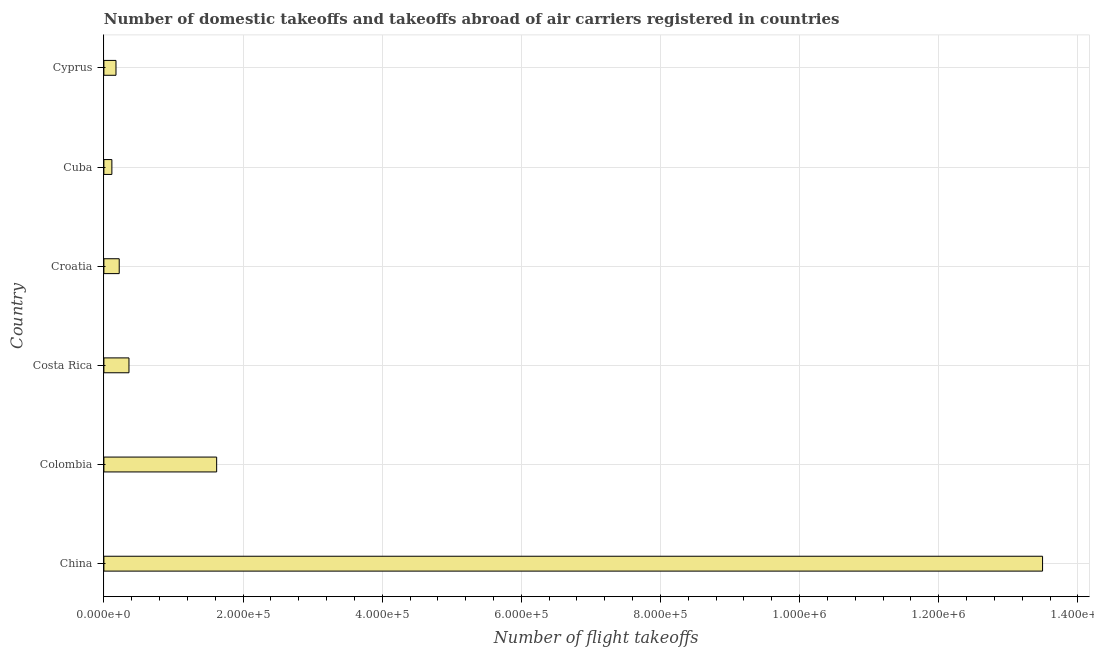Does the graph contain grids?
Offer a terse response. Yes. What is the title of the graph?
Offer a very short reply. Number of domestic takeoffs and takeoffs abroad of air carriers registered in countries. What is the label or title of the X-axis?
Give a very brief answer. Number of flight takeoffs. What is the number of flight takeoffs in China?
Give a very brief answer. 1.35e+06. Across all countries, what is the maximum number of flight takeoffs?
Give a very brief answer. 1.35e+06. Across all countries, what is the minimum number of flight takeoffs?
Make the answer very short. 1.15e+04. In which country was the number of flight takeoffs minimum?
Provide a succinct answer. Cuba. What is the sum of the number of flight takeoffs?
Offer a terse response. 1.60e+06. What is the difference between the number of flight takeoffs in Colombia and Croatia?
Offer a very short reply. 1.40e+05. What is the average number of flight takeoffs per country?
Offer a very short reply. 2.66e+05. What is the median number of flight takeoffs?
Keep it short and to the point. 2.90e+04. What is the ratio of the number of flight takeoffs in Colombia to that in Costa Rica?
Your answer should be compact. 4.5. Is the number of flight takeoffs in Costa Rica less than that in Croatia?
Provide a short and direct response. No. What is the difference between the highest and the second highest number of flight takeoffs?
Provide a short and direct response. 1.19e+06. Is the sum of the number of flight takeoffs in Cuba and Cyprus greater than the maximum number of flight takeoffs across all countries?
Provide a short and direct response. No. What is the difference between the highest and the lowest number of flight takeoffs?
Keep it short and to the point. 1.34e+06. How many countries are there in the graph?
Your response must be concise. 6. What is the difference between two consecutive major ticks on the X-axis?
Your answer should be very brief. 2.00e+05. What is the Number of flight takeoffs in China?
Your response must be concise. 1.35e+06. What is the Number of flight takeoffs of Colombia?
Give a very brief answer. 1.62e+05. What is the Number of flight takeoffs of Costa Rica?
Give a very brief answer. 3.60e+04. What is the Number of flight takeoffs in Croatia?
Offer a very short reply. 2.20e+04. What is the Number of flight takeoffs in Cuba?
Make the answer very short. 1.15e+04. What is the Number of flight takeoffs of Cyprus?
Offer a very short reply. 1.74e+04. What is the difference between the Number of flight takeoffs in China and Colombia?
Ensure brevity in your answer.  1.19e+06. What is the difference between the Number of flight takeoffs in China and Costa Rica?
Give a very brief answer. 1.31e+06. What is the difference between the Number of flight takeoffs in China and Croatia?
Your response must be concise. 1.33e+06. What is the difference between the Number of flight takeoffs in China and Cuba?
Your answer should be very brief. 1.34e+06. What is the difference between the Number of flight takeoffs in China and Cyprus?
Provide a short and direct response. 1.33e+06. What is the difference between the Number of flight takeoffs in Colombia and Costa Rica?
Your response must be concise. 1.26e+05. What is the difference between the Number of flight takeoffs in Colombia and Croatia?
Provide a succinct answer. 1.40e+05. What is the difference between the Number of flight takeoffs in Colombia and Cuba?
Your answer should be compact. 1.51e+05. What is the difference between the Number of flight takeoffs in Colombia and Cyprus?
Make the answer very short. 1.45e+05. What is the difference between the Number of flight takeoffs in Costa Rica and Croatia?
Your answer should be compact. 1.40e+04. What is the difference between the Number of flight takeoffs in Costa Rica and Cuba?
Keep it short and to the point. 2.46e+04. What is the difference between the Number of flight takeoffs in Costa Rica and Cyprus?
Your answer should be compact. 1.87e+04. What is the difference between the Number of flight takeoffs in Croatia and Cuba?
Your answer should be compact. 1.05e+04. What is the difference between the Number of flight takeoffs in Croatia and Cyprus?
Give a very brief answer. 4639. What is the difference between the Number of flight takeoffs in Cuba and Cyprus?
Make the answer very short. -5908. What is the ratio of the Number of flight takeoffs in China to that in Colombia?
Provide a succinct answer. 8.32. What is the ratio of the Number of flight takeoffs in China to that in Costa Rica?
Your response must be concise. 37.43. What is the ratio of the Number of flight takeoffs in China to that in Croatia?
Ensure brevity in your answer.  61.24. What is the ratio of the Number of flight takeoffs in China to that in Cuba?
Provide a succinct answer. 117.49. What is the ratio of the Number of flight takeoffs in China to that in Cyprus?
Give a very brief answer. 77.58. What is the ratio of the Number of flight takeoffs in Colombia to that in Costa Rica?
Your answer should be compact. 4.5. What is the ratio of the Number of flight takeoffs in Colombia to that in Croatia?
Keep it short and to the point. 7.36. What is the ratio of the Number of flight takeoffs in Colombia to that in Cuba?
Your response must be concise. 14.12. What is the ratio of the Number of flight takeoffs in Colombia to that in Cyprus?
Your answer should be compact. 9.32. What is the ratio of the Number of flight takeoffs in Costa Rica to that in Croatia?
Give a very brief answer. 1.64. What is the ratio of the Number of flight takeoffs in Costa Rica to that in Cuba?
Provide a short and direct response. 3.14. What is the ratio of the Number of flight takeoffs in Costa Rica to that in Cyprus?
Give a very brief answer. 2.07. What is the ratio of the Number of flight takeoffs in Croatia to that in Cuba?
Offer a terse response. 1.92. What is the ratio of the Number of flight takeoffs in Croatia to that in Cyprus?
Provide a succinct answer. 1.27. What is the ratio of the Number of flight takeoffs in Cuba to that in Cyprus?
Make the answer very short. 0.66. 